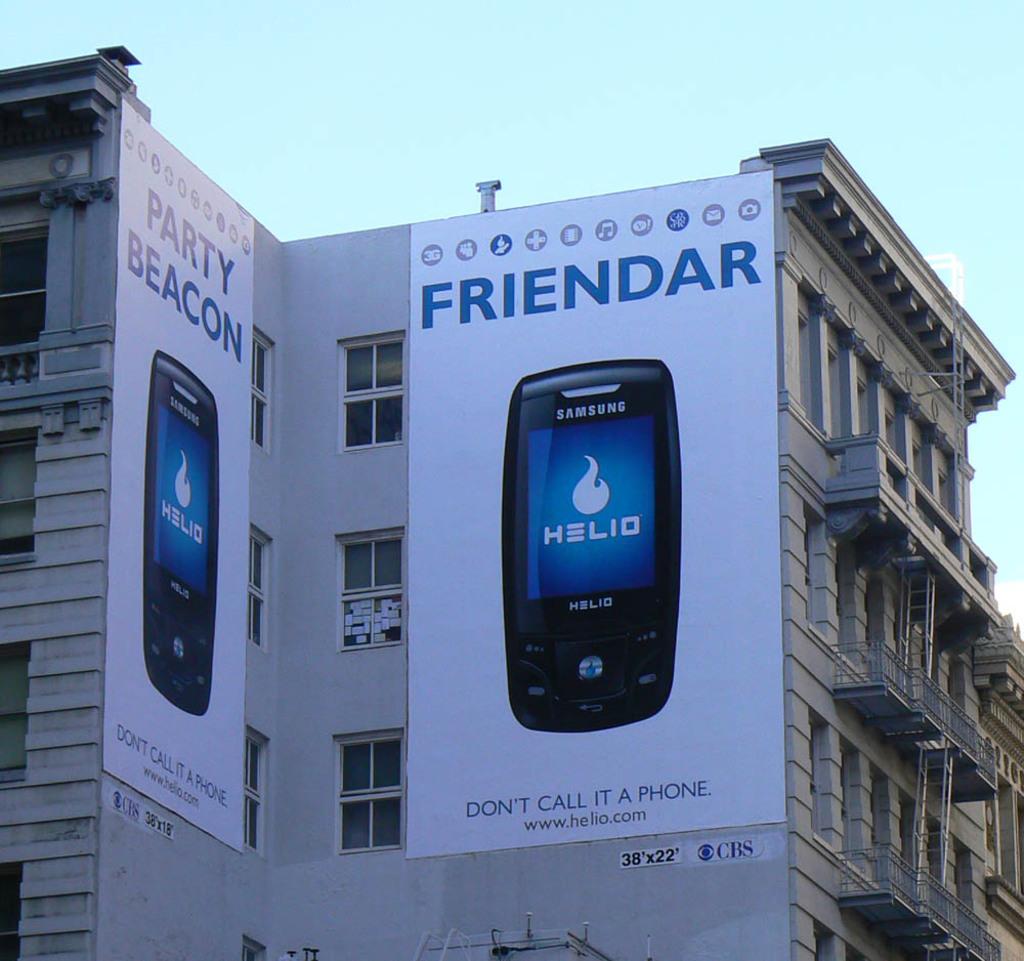What logo is on the phone scereen?
Keep it short and to the point. Helio. What is the slogan under the phone?
Provide a short and direct response. Don't call it a phone. 